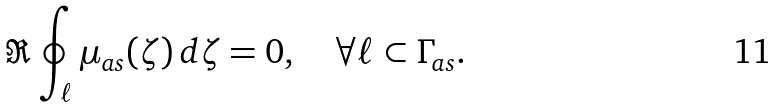<formula> <loc_0><loc_0><loc_500><loc_500>\Re \oint _ { \ell } \mu _ { a s } ( \zeta ) \, d \zeta = 0 , \quad \forall \ell \subset \Gamma _ { a s } .</formula> 